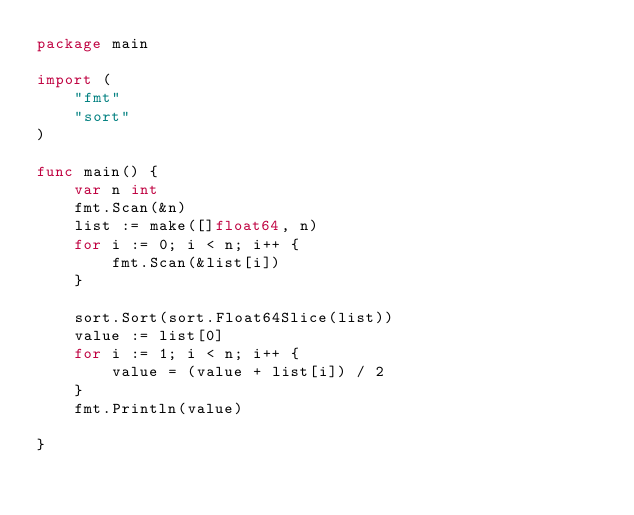<code> <loc_0><loc_0><loc_500><loc_500><_Go_>package main

import (
	"fmt"
	"sort"
)

func main() {
	var n int
	fmt.Scan(&n)
	list := make([]float64, n)
	for i := 0; i < n; i++ {
		fmt.Scan(&list[i])
	}

	sort.Sort(sort.Float64Slice(list))
	value := list[0]
	for i := 1; i < n; i++ {
		value = (value + list[i]) / 2
	}
	fmt.Println(value)

}
</code> 